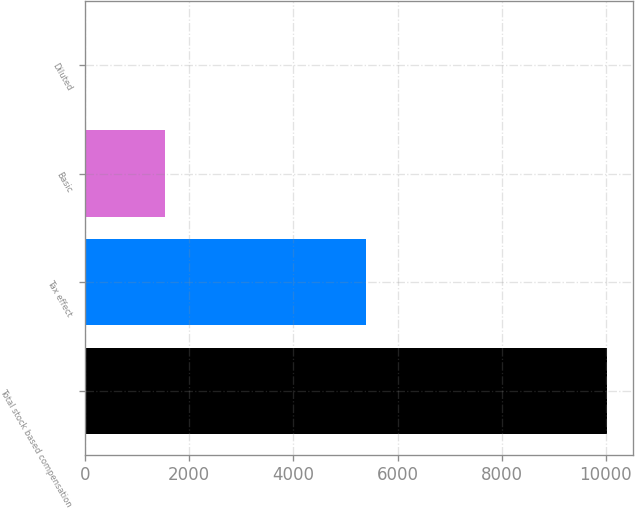Convert chart to OTSL. <chart><loc_0><loc_0><loc_500><loc_500><bar_chart><fcel>Total stock based compensation<fcel>Tax effect<fcel>Basic<fcel>Diluted<nl><fcel>10020<fcel>5395<fcel>1541.6<fcel>0.11<nl></chart> 